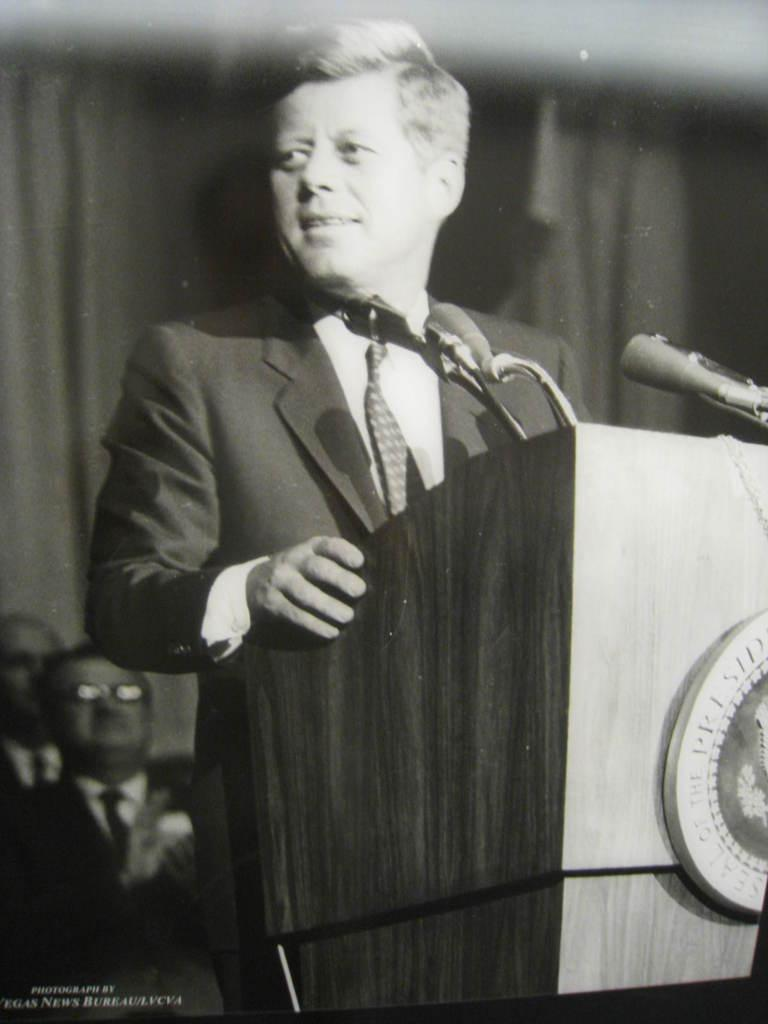What is the man in the image wearing? The man is wearing a blazer and a tie. What is the man doing in the image? The man is standing at a podium. What is in front of the man at the podium? There are microphones in front of the man. How many men are visible in the background of the image? There are two men in the background of the image. What type of pie is being served at the event in the image? There is no pie present in the image, nor is there any indication of an event taking place. 